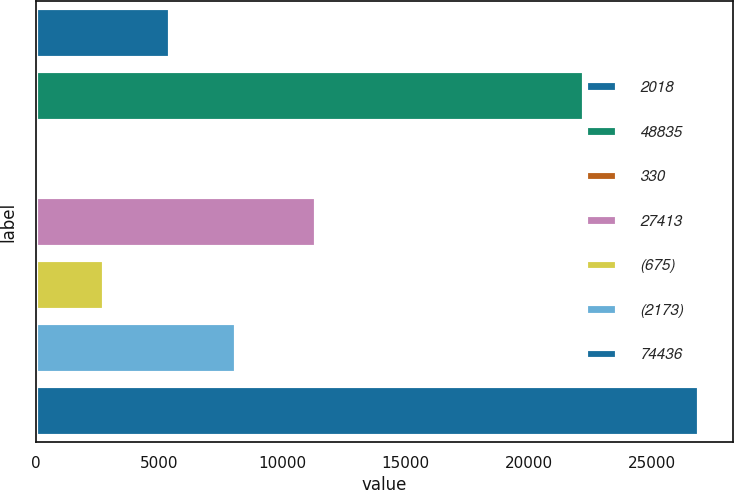<chart> <loc_0><loc_0><loc_500><loc_500><bar_chart><fcel>2018<fcel>48835<fcel>330<fcel>27413<fcel>(675)<fcel>(2173)<fcel>74436<nl><fcel>5419.8<fcel>22239<fcel>46<fcel>11359<fcel>2732.9<fcel>8106.7<fcel>26915<nl></chart> 